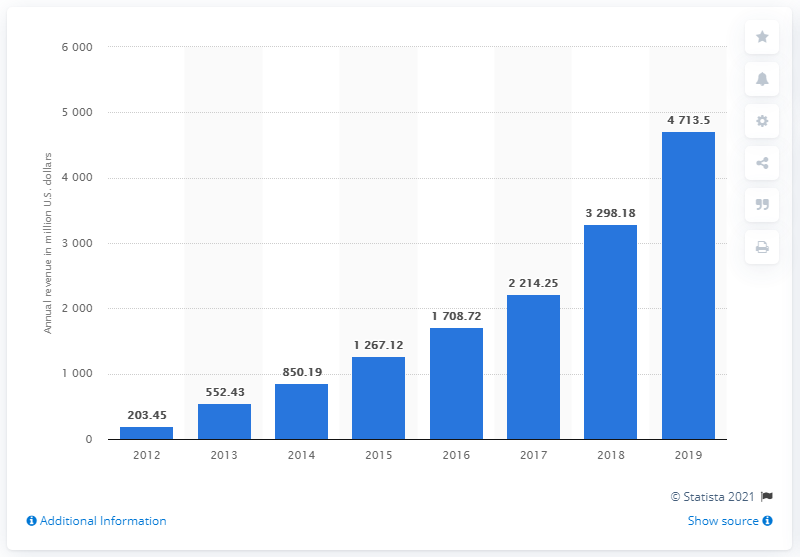Identify some key points in this picture. Square's net revenue in the previous year was 3,298.18. In the most recent year, Square's net revenues were $47,13.5 million. 